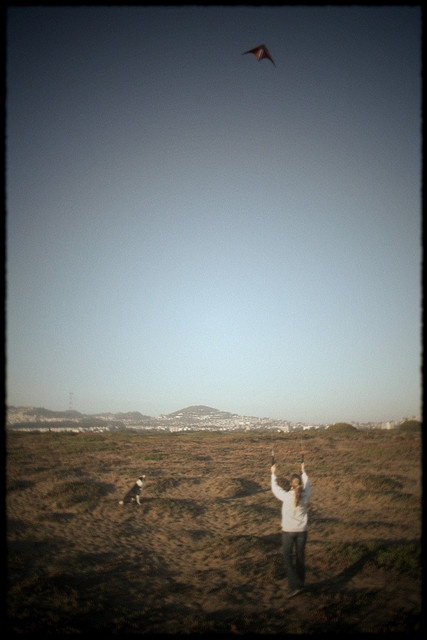Describe the objects in this image and their specific colors. I can see people in black, tan, and gray tones, dog in black and gray tones, and kite in black, maroon, and gray tones in this image. 